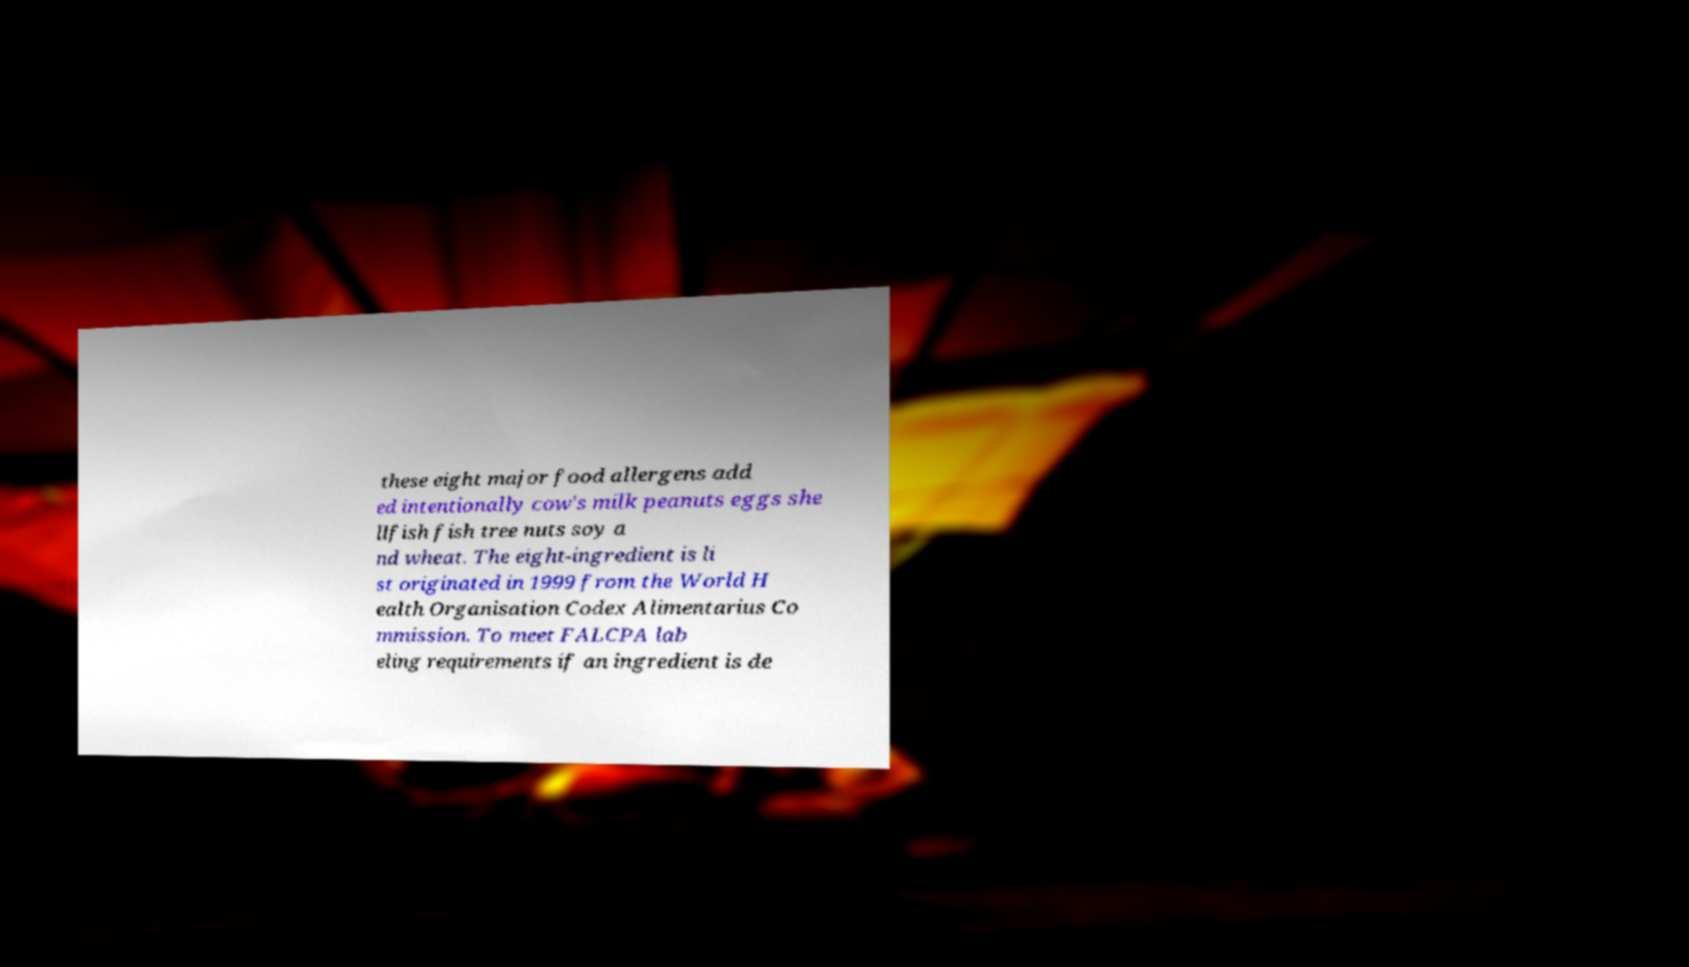Can you read and provide the text displayed in the image?This photo seems to have some interesting text. Can you extract and type it out for me? these eight major food allergens add ed intentionally cow's milk peanuts eggs she llfish fish tree nuts soy a nd wheat. The eight-ingredient is li st originated in 1999 from the World H ealth Organisation Codex Alimentarius Co mmission. To meet FALCPA lab eling requirements if an ingredient is de 